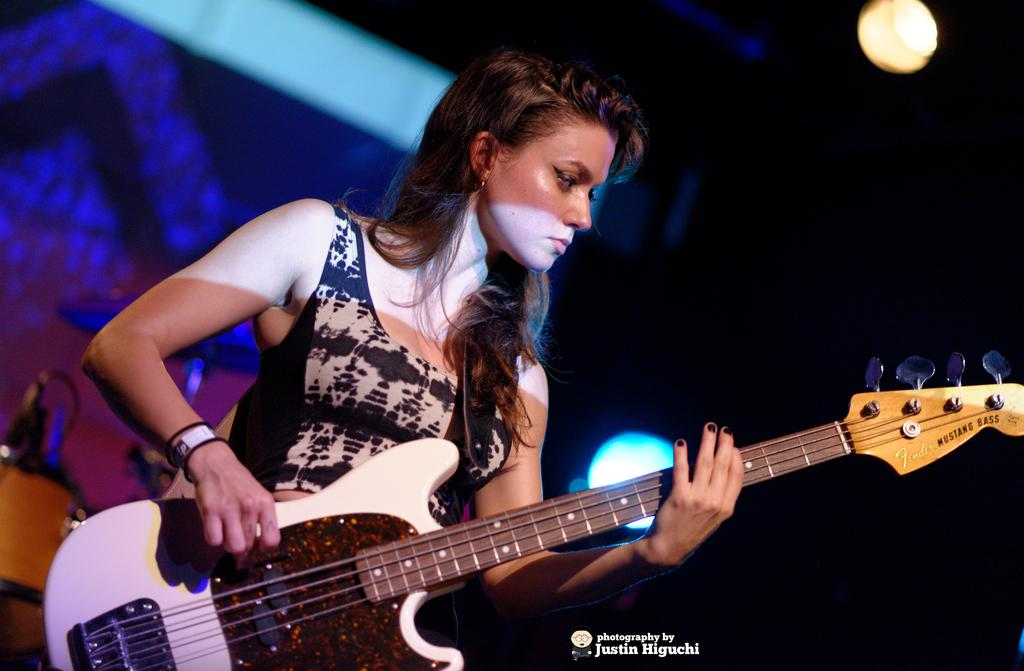Who is the main subject in the image? There is a girl in the image. What is the girl holding in the image? The girl is holding a guitar. What can be seen on the left side of the image? There is a stage on the left side of the image. What is located above the image? There is a lamp above the image. Can you see any grains of rice on the stage in the image? There is no mention of rice or grains in the image, so it cannot be determined if they are present. 